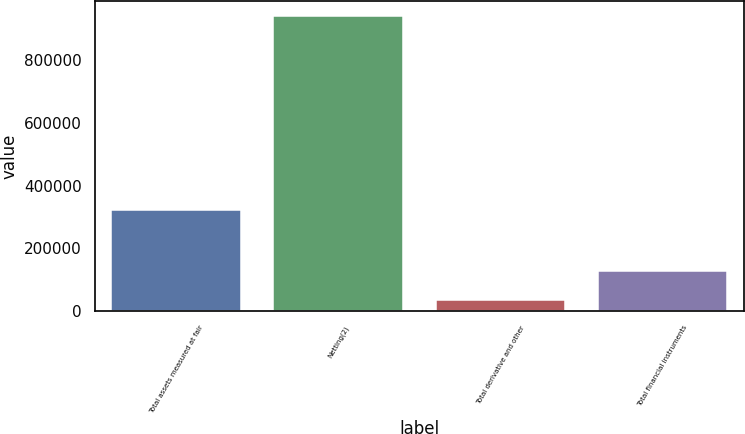Convert chart. <chart><loc_0><loc_0><loc_500><loc_500><bar_chart><fcel>Total assets measured at fair<fcel>Netting(2)<fcel>Total derivative and other<fcel>Total financial instruments<nl><fcel>322378<fcel>941815<fcel>36958<fcel>127444<nl></chart> 